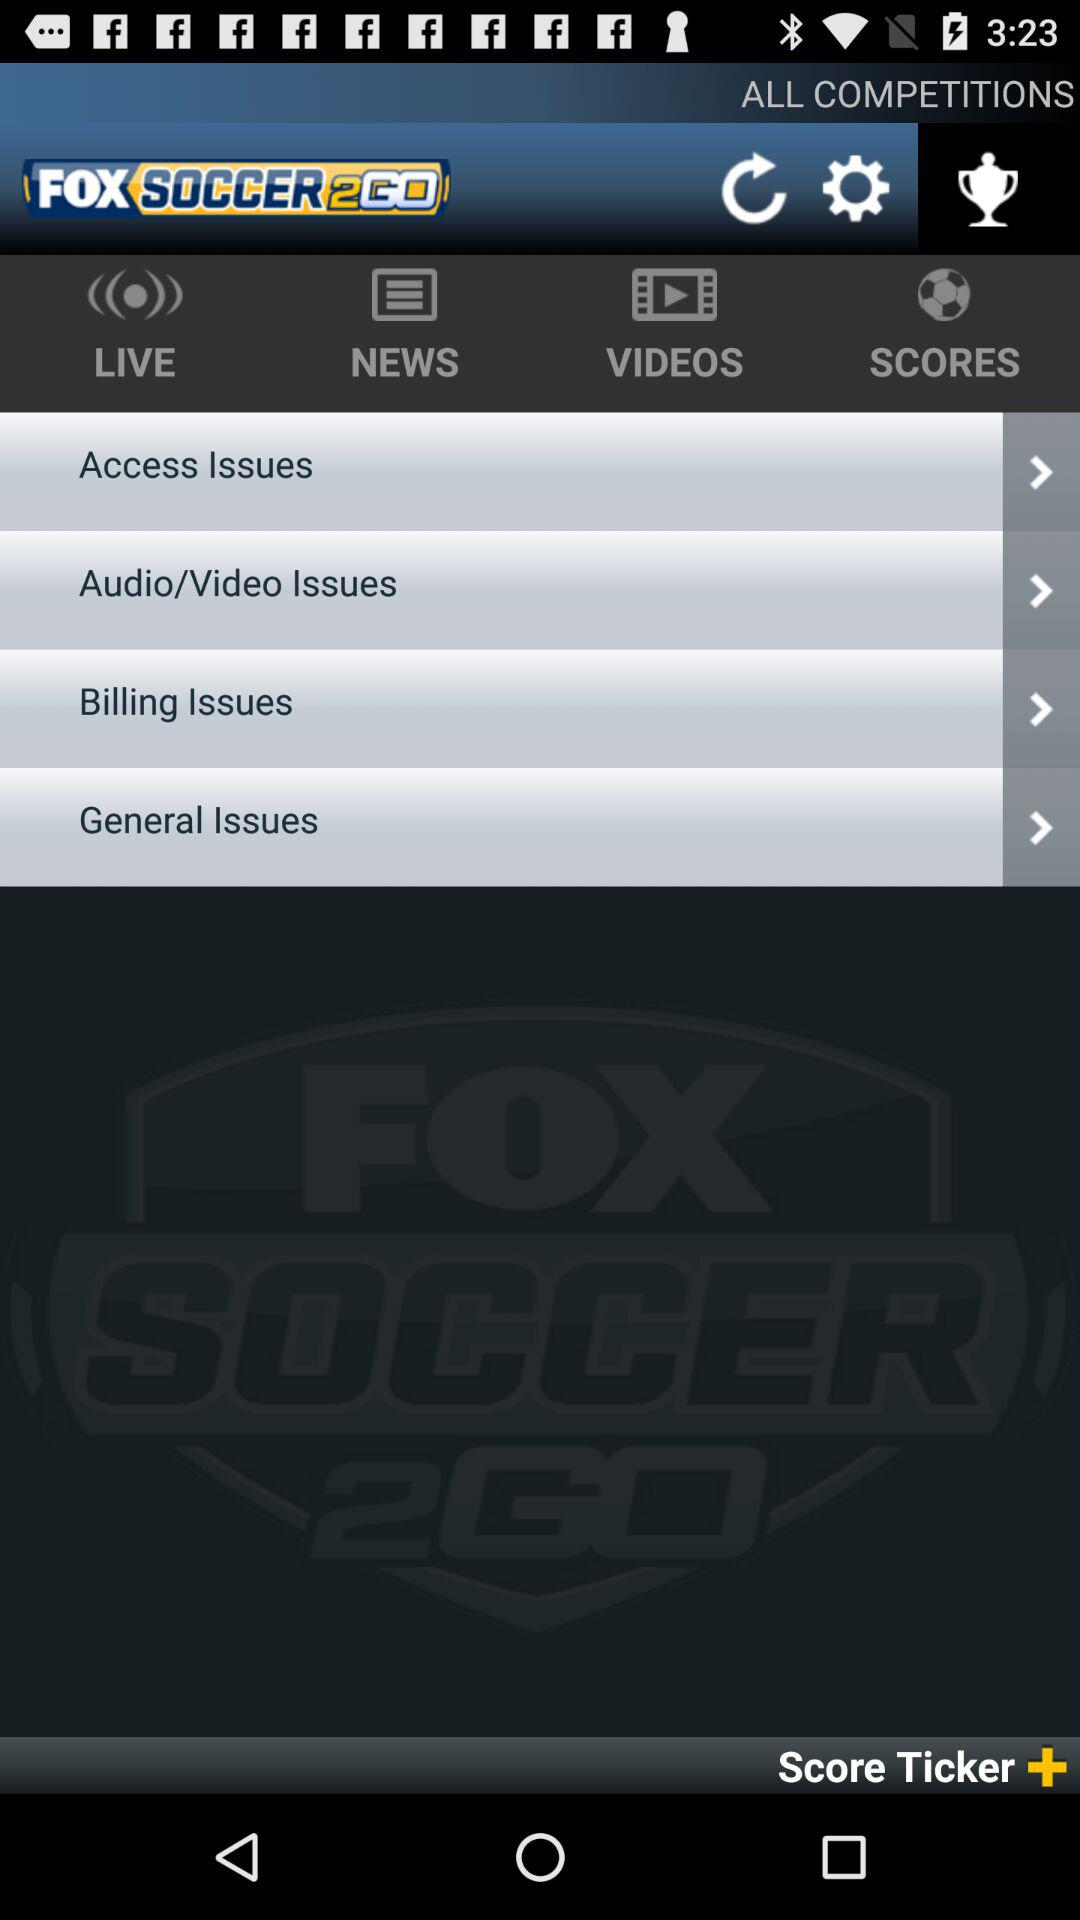What is the name of the application? The name of the application is "FOX SOCCER 2GO". 